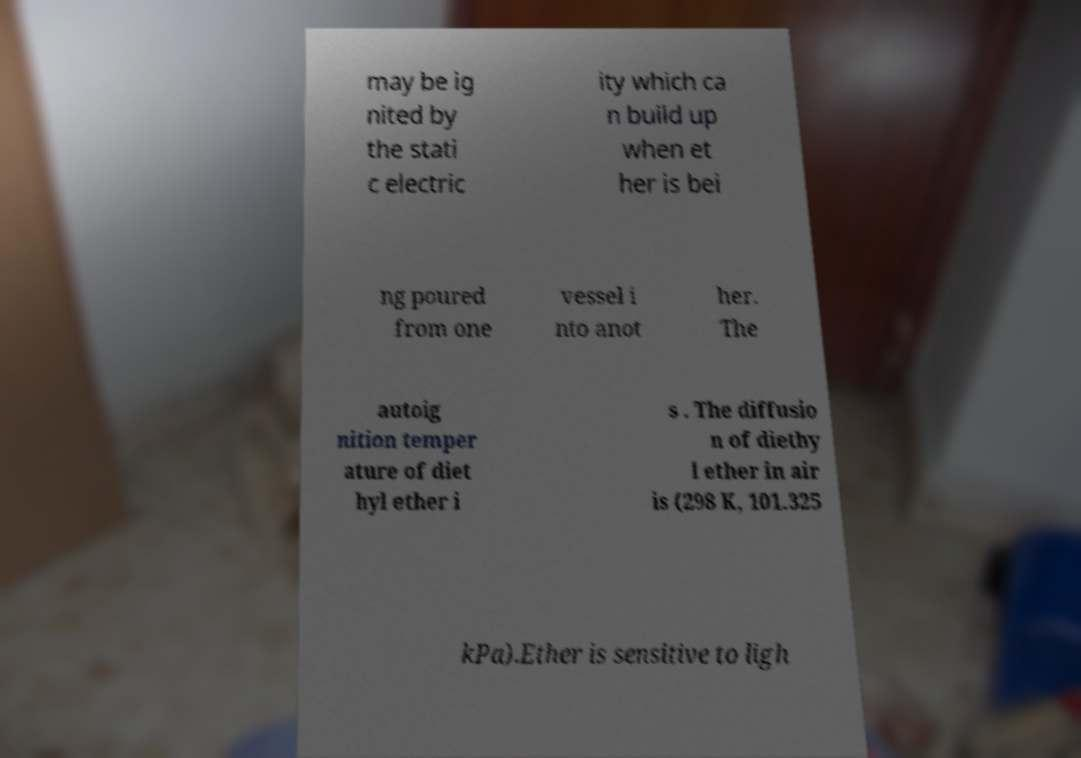Could you assist in decoding the text presented in this image and type it out clearly? may be ig nited by the stati c electric ity which ca n build up when et her is bei ng poured from one vessel i nto anot her. The autoig nition temper ature of diet hyl ether i s . The diffusio n of diethy l ether in air is (298 K, 101.325 kPa).Ether is sensitive to ligh 